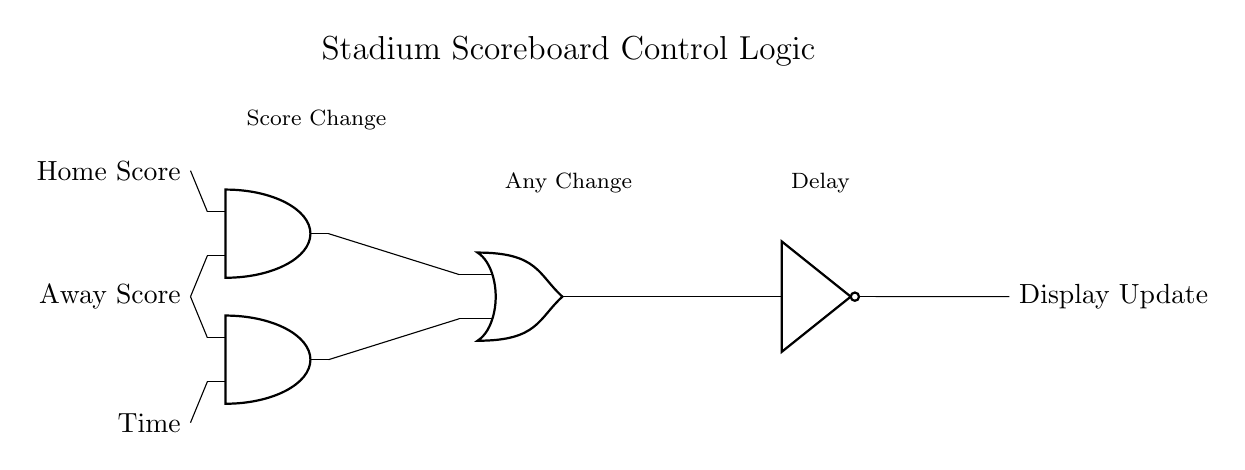What are the inputs of the AND gates? The inputs of the AND gates are the Home Score, Away Score, and Time signals. The first AND gate takes the Home Score and Away Score, while the second AND gate takes the Away Score and Time.
Answer: Home Score, Away Score, Time How many logic gates are used in this circuit? There are four logic gates used in this circuit: two AND gates, one OR gate, and one NOT gate, which are all indicated by their respective symbols in the diagram.
Answer: Four What is the purpose of the NOT gate? The NOT gate inverts the output from the OR gate, meaning it changes a high signal to low and vice versa. Its inclusion ensures that the display update signal reflects the opposite of the combined AND gate outputs.
Answer: Invert signal What does the output of the circuit represent? The output of the circuit represents the Display Update signal, which indicates when the scoreboard display needs to be refreshed or updated based on the score changes.
Answer: Display Update If both scores change, what is the output of the OR gate? If both scores change, the first AND gate outputs a high signal, making the OR gate output high. Therefore, the combination will trigger the NOT gate to invert this to low, which signifies an update is not needed if the timer is counted down or other logic applies.
Answer: Low What conditions lead to a high output on the first AND gate? The conditions leading to a high output on the first AND gate are that both the Home Score and Away Score must be high, meaning both teams have scored. This output can then be used for further processing in the circuit.
Answer: Home and Away scored 